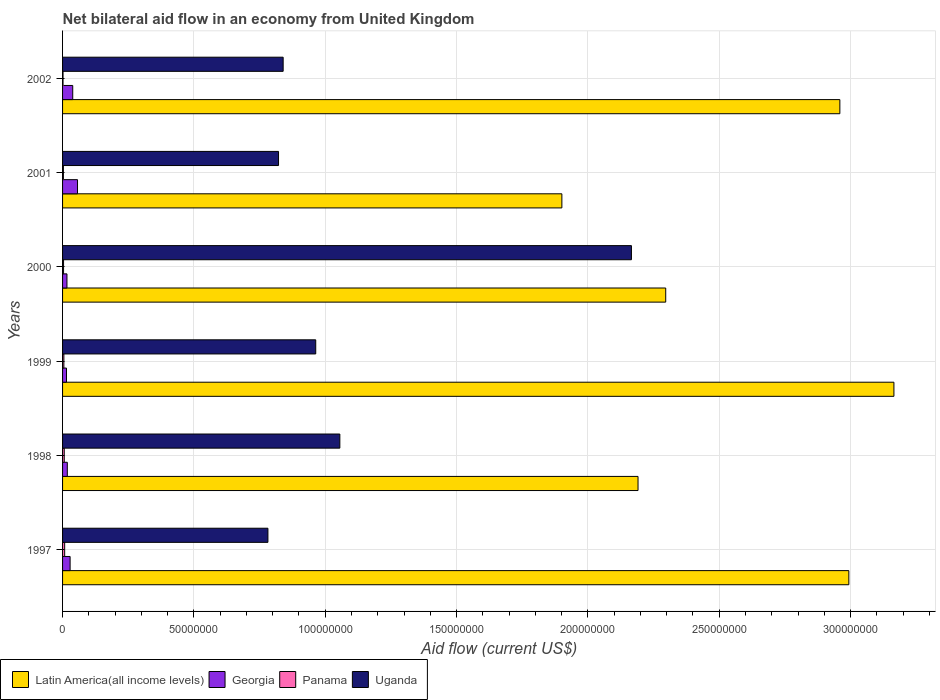How many groups of bars are there?
Provide a short and direct response. 6. Are the number of bars per tick equal to the number of legend labels?
Offer a terse response. Yes. Are the number of bars on each tick of the Y-axis equal?
Ensure brevity in your answer.  Yes. What is the label of the 6th group of bars from the top?
Provide a succinct answer. 1997. In how many cases, is the number of bars for a given year not equal to the number of legend labels?
Ensure brevity in your answer.  0. What is the net bilateral aid flow in Latin America(all income levels) in 1997?
Make the answer very short. 2.99e+08. Across all years, what is the minimum net bilateral aid flow in Georgia?
Your response must be concise. 1.50e+06. What is the total net bilateral aid flow in Panama in the graph?
Keep it short and to the point. 2.82e+06. What is the difference between the net bilateral aid flow in Latin America(all income levels) in 1998 and the net bilateral aid flow in Georgia in 2002?
Provide a succinct answer. 2.15e+08. In the year 1997, what is the difference between the net bilateral aid flow in Uganda and net bilateral aid flow in Panama?
Your answer should be compact. 7.74e+07. What is the ratio of the net bilateral aid flow in Latin America(all income levels) in 2001 to that in 2002?
Your response must be concise. 0.64. Is the net bilateral aid flow in Georgia in 1997 less than that in 2000?
Provide a short and direct response. No. Is the difference between the net bilateral aid flow in Uganda in 1998 and 2002 greater than the difference between the net bilateral aid flow in Panama in 1998 and 2002?
Give a very brief answer. Yes. What is the difference between the highest and the second highest net bilateral aid flow in Georgia?
Make the answer very short. 1.82e+06. What is the difference between the highest and the lowest net bilateral aid flow in Panama?
Your response must be concise. 6.20e+05. Is the sum of the net bilateral aid flow in Georgia in 2000 and 2002 greater than the maximum net bilateral aid flow in Panama across all years?
Give a very brief answer. Yes. Is it the case that in every year, the sum of the net bilateral aid flow in Georgia and net bilateral aid flow in Uganda is greater than the sum of net bilateral aid flow in Panama and net bilateral aid flow in Latin America(all income levels)?
Make the answer very short. Yes. What does the 4th bar from the top in 1999 represents?
Make the answer very short. Latin America(all income levels). What does the 2nd bar from the bottom in 1999 represents?
Provide a short and direct response. Georgia. Is it the case that in every year, the sum of the net bilateral aid flow in Panama and net bilateral aid flow in Georgia is greater than the net bilateral aid flow in Uganda?
Provide a short and direct response. No. Are all the bars in the graph horizontal?
Provide a short and direct response. Yes. How many years are there in the graph?
Provide a short and direct response. 6. What is the difference between two consecutive major ticks on the X-axis?
Offer a terse response. 5.00e+07. Does the graph contain any zero values?
Offer a very short reply. No. Where does the legend appear in the graph?
Your response must be concise. Bottom left. How are the legend labels stacked?
Offer a terse response. Horizontal. What is the title of the graph?
Your answer should be compact. Net bilateral aid flow in an economy from United Kingdom. What is the label or title of the Y-axis?
Give a very brief answer. Years. What is the Aid flow (current US$) of Latin America(all income levels) in 1997?
Your answer should be compact. 2.99e+08. What is the Aid flow (current US$) of Georgia in 1997?
Offer a very short reply. 2.87e+06. What is the Aid flow (current US$) in Panama in 1997?
Make the answer very short. 8.00e+05. What is the Aid flow (current US$) of Uganda in 1997?
Keep it short and to the point. 7.82e+07. What is the Aid flow (current US$) of Latin America(all income levels) in 1998?
Provide a succinct answer. 2.19e+08. What is the Aid flow (current US$) of Georgia in 1998?
Your answer should be compact. 1.81e+06. What is the Aid flow (current US$) of Panama in 1998?
Ensure brevity in your answer.  6.40e+05. What is the Aid flow (current US$) of Uganda in 1998?
Give a very brief answer. 1.06e+08. What is the Aid flow (current US$) in Latin America(all income levels) in 1999?
Offer a very short reply. 3.16e+08. What is the Aid flow (current US$) in Georgia in 1999?
Your response must be concise. 1.50e+06. What is the Aid flow (current US$) in Panama in 1999?
Make the answer very short. 5.00e+05. What is the Aid flow (current US$) in Uganda in 1999?
Ensure brevity in your answer.  9.64e+07. What is the Aid flow (current US$) in Latin America(all income levels) in 2000?
Offer a very short reply. 2.30e+08. What is the Aid flow (current US$) of Georgia in 2000?
Give a very brief answer. 1.67e+06. What is the Aid flow (current US$) of Uganda in 2000?
Your answer should be very brief. 2.17e+08. What is the Aid flow (current US$) of Latin America(all income levels) in 2001?
Your answer should be compact. 1.90e+08. What is the Aid flow (current US$) in Georgia in 2001?
Offer a very short reply. 5.69e+06. What is the Aid flow (current US$) in Uganda in 2001?
Give a very brief answer. 8.22e+07. What is the Aid flow (current US$) of Latin America(all income levels) in 2002?
Provide a succinct answer. 2.96e+08. What is the Aid flow (current US$) of Georgia in 2002?
Your answer should be very brief. 3.87e+06. What is the Aid flow (current US$) in Uganda in 2002?
Ensure brevity in your answer.  8.40e+07. Across all years, what is the maximum Aid flow (current US$) of Latin America(all income levels)?
Make the answer very short. 3.16e+08. Across all years, what is the maximum Aid flow (current US$) of Georgia?
Keep it short and to the point. 5.69e+06. Across all years, what is the maximum Aid flow (current US$) in Panama?
Your answer should be very brief. 8.00e+05. Across all years, what is the maximum Aid flow (current US$) of Uganda?
Keep it short and to the point. 2.17e+08. Across all years, what is the minimum Aid flow (current US$) in Latin America(all income levels)?
Your answer should be compact. 1.90e+08. Across all years, what is the minimum Aid flow (current US$) in Georgia?
Your answer should be compact. 1.50e+06. Across all years, what is the minimum Aid flow (current US$) in Panama?
Make the answer very short. 1.80e+05. Across all years, what is the minimum Aid flow (current US$) of Uganda?
Your answer should be very brief. 7.82e+07. What is the total Aid flow (current US$) of Latin America(all income levels) in the graph?
Ensure brevity in your answer.  1.55e+09. What is the total Aid flow (current US$) in Georgia in the graph?
Your answer should be compact. 1.74e+07. What is the total Aid flow (current US$) in Panama in the graph?
Give a very brief answer. 2.82e+06. What is the total Aid flow (current US$) of Uganda in the graph?
Offer a very short reply. 6.63e+08. What is the difference between the Aid flow (current US$) of Latin America(all income levels) in 1997 and that in 1998?
Offer a very short reply. 8.03e+07. What is the difference between the Aid flow (current US$) in Georgia in 1997 and that in 1998?
Your answer should be very brief. 1.06e+06. What is the difference between the Aid flow (current US$) in Uganda in 1997 and that in 1998?
Provide a short and direct response. -2.74e+07. What is the difference between the Aid flow (current US$) in Latin America(all income levels) in 1997 and that in 1999?
Your answer should be compact. -1.72e+07. What is the difference between the Aid flow (current US$) in Georgia in 1997 and that in 1999?
Offer a terse response. 1.37e+06. What is the difference between the Aid flow (current US$) of Panama in 1997 and that in 1999?
Keep it short and to the point. 3.00e+05. What is the difference between the Aid flow (current US$) of Uganda in 1997 and that in 1999?
Offer a terse response. -1.82e+07. What is the difference between the Aid flow (current US$) in Latin America(all income levels) in 1997 and that in 2000?
Ensure brevity in your answer.  6.97e+07. What is the difference between the Aid flow (current US$) of Georgia in 1997 and that in 2000?
Ensure brevity in your answer.  1.20e+06. What is the difference between the Aid flow (current US$) of Uganda in 1997 and that in 2000?
Offer a terse response. -1.38e+08. What is the difference between the Aid flow (current US$) of Latin America(all income levels) in 1997 and that in 2001?
Your response must be concise. 1.09e+08. What is the difference between the Aid flow (current US$) in Georgia in 1997 and that in 2001?
Provide a succinct answer. -2.82e+06. What is the difference between the Aid flow (current US$) of Uganda in 1997 and that in 2001?
Provide a short and direct response. -4.04e+06. What is the difference between the Aid flow (current US$) of Latin America(all income levels) in 1997 and that in 2002?
Your answer should be compact. 3.42e+06. What is the difference between the Aid flow (current US$) of Georgia in 1997 and that in 2002?
Your answer should be very brief. -1.00e+06. What is the difference between the Aid flow (current US$) of Panama in 1997 and that in 2002?
Provide a short and direct response. 6.20e+05. What is the difference between the Aid flow (current US$) of Uganda in 1997 and that in 2002?
Offer a very short reply. -5.80e+06. What is the difference between the Aid flow (current US$) in Latin America(all income levels) in 1998 and that in 1999?
Keep it short and to the point. -9.74e+07. What is the difference between the Aid flow (current US$) of Georgia in 1998 and that in 1999?
Offer a terse response. 3.10e+05. What is the difference between the Aid flow (current US$) of Uganda in 1998 and that in 1999?
Ensure brevity in your answer.  9.18e+06. What is the difference between the Aid flow (current US$) in Latin America(all income levels) in 1998 and that in 2000?
Give a very brief answer. -1.05e+07. What is the difference between the Aid flow (current US$) in Panama in 1998 and that in 2000?
Offer a terse response. 2.60e+05. What is the difference between the Aid flow (current US$) of Uganda in 1998 and that in 2000?
Offer a very short reply. -1.11e+08. What is the difference between the Aid flow (current US$) of Latin America(all income levels) in 1998 and that in 2001?
Give a very brief answer. 2.90e+07. What is the difference between the Aid flow (current US$) of Georgia in 1998 and that in 2001?
Your response must be concise. -3.88e+06. What is the difference between the Aid flow (current US$) in Uganda in 1998 and that in 2001?
Give a very brief answer. 2.33e+07. What is the difference between the Aid flow (current US$) in Latin America(all income levels) in 1998 and that in 2002?
Your answer should be compact. -7.68e+07. What is the difference between the Aid flow (current US$) of Georgia in 1998 and that in 2002?
Make the answer very short. -2.06e+06. What is the difference between the Aid flow (current US$) in Uganda in 1998 and that in 2002?
Offer a terse response. 2.16e+07. What is the difference between the Aid flow (current US$) in Latin America(all income levels) in 1999 and that in 2000?
Your answer should be compact. 8.69e+07. What is the difference between the Aid flow (current US$) of Georgia in 1999 and that in 2000?
Ensure brevity in your answer.  -1.70e+05. What is the difference between the Aid flow (current US$) in Uganda in 1999 and that in 2000?
Offer a terse response. -1.20e+08. What is the difference between the Aid flow (current US$) of Latin America(all income levels) in 1999 and that in 2001?
Your answer should be very brief. 1.26e+08. What is the difference between the Aid flow (current US$) in Georgia in 1999 and that in 2001?
Keep it short and to the point. -4.19e+06. What is the difference between the Aid flow (current US$) of Uganda in 1999 and that in 2001?
Keep it short and to the point. 1.42e+07. What is the difference between the Aid flow (current US$) of Latin America(all income levels) in 1999 and that in 2002?
Make the answer very short. 2.06e+07. What is the difference between the Aid flow (current US$) of Georgia in 1999 and that in 2002?
Provide a succinct answer. -2.37e+06. What is the difference between the Aid flow (current US$) in Uganda in 1999 and that in 2002?
Your response must be concise. 1.24e+07. What is the difference between the Aid flow (current US$) of Latin America(all income levels) in 2000 and that in 2001?
Offer a terse response. 3.95e+07. What is the difference between the Aid flow (current US$) in Georgia in 2000 and that in 2001?
Offer a very short reply. -4.02e+06. What is the difference between the Aid flow (current US$) in Panama in 2000 and that in 2001?
Keep it short and to the point. 6.00e+04. What is the difference between the Aid flow (current US$) of Uganda in 2000 and that in 2001?
Offer a very short reply. 1.34e+08. What is the difference between the Aid flow (current US$) of Latin America(all income levels) in 2000 and that in 2002?
Give a very brief answer. -6.63e+07. What is the difference between the Aid flow (current US$) of Georgia in 2000 and that in 2002?
Keep it short and to the point. -2.20e+06. What is the difference between the Aid flow (current US$) of Uganda in 2000 and that in 2002?
Offer a terse response. 1.33e+08. What is the difference between the Aid flow (current US$) of Latin America(all income levels) in 2001 and that in 2002?
Offer a very short reply. -1.06e+08. What is the difference between the Aid flow (current US$) of Georgia in 2001 and that in 2002?
Your response must be concise. 1.82e+06. What is the difference between the Aid flow (current US$) of Uganda in 2001 and that in 2002?
Ensure brevity in your answer.  -1.76e+06. What is the difference between the Aid flow (current US$) of Latin America(all income levels) in 1997 and the Aid flow (current US$) of Georgia in 1998?
Offer a terse response. 2.98e+08. What is the difference between the Aid flow (current US$) in Latin America(all income levels) in 1997 and the Aid flow (current US$) in Panama in 1998?
Your answer should be compact. 2.99e+08. What is the difference between the Aid flow (current US$) in Latin America(all income levels) in 1997 and the Aid flow (current US$) in Uganda in 1998?
Keep it short and to the point. 1.94e+08. What is the difference between the Aid flow (current US$) of Georgia in 1997 and the Aid flow (current US$) of Panama in 1998?
Offer a very short reply. 2.23e+06. What is the difference between the Aid flow (current US$) of Georgia in 1997 and the Aid flow (current US$) of Uganda in 1998?
Your answer should be compact. -1.03e+08. What is the difference between the Aid flow (current US$) in Panama in 1997 and the Aid flow (current US$) in Uganda in 1998?
Offer a terse response. -1.05e+08. What is the difference between the Aid flow (current US$) of Latin America(all income levels) in 1997 and the Aid flow (current US$) of Georgia in 1999?
Offer a very short reply. 2.98e+08. What is the difference between the Aid flow (current US$) in Latin America(all income levels) in 1997 and the Aid flow (current US$) in Panama in 1999?
Offer a terse response. 2.99e+08. What is the difference between the Aid flow (current US$) of Latin America(all income levels) in 1997 and the Aid flow (current US$) of Uganda in 1999?
Offer a terse response. 2.03e+08. What is the difference between the Aid flow (current US$) of Georgia in 1997 and the Aid flow (current US$) of Panama in 1999?
Offer a very short reply. 2.37e+06. What is the difference between the Aid flow (current US$) in Georgia in 1997 and the Aid flow (current US$) in Uganda in 1999?
Give a very brief answer. -9.35e+07. What is the difference between the Aid flow (current US$) in Panama in 1997 and the Aid flow (current US$) in Uganda in 1999?
Your answer should be very brief. -9.56e+07. What is the difference between the Aid flow (current US$) in Latin America(all income levels) in 1997 and the Aid flow (current US$) in Georgia in 2000?
Ensure brevity in your answer.  2.98e+08. What is the difference between the Aid flow (current US$) in Latin America(all income levels) in 1997 and the Aid flow (current US$) in Panama in 2000?
Make the answer very short. 2.99e+08. What is the difference between the Aid flow (current US$) of Latin America(all income levels) in 1997 and the Aid flow (current US$) of Uganda in 2000?
Your response must be concise. 8.28e+07. What is the difference between the Aid flow (current US$) of Georgia in 1997 and the Aid flow (current US$) of Panama in 2000?
Keep it short and to the point. 2.49e+06. What is the difference between the Aid flow (current US$) of Georgia in 1997 and the Aid flow (current US$) of Uganda in 2000?
Keep it short and to the point. -2.14e+08. What is the difference between the Aid flow (current US$) in Panama in 1997 and the Aid flow (current US$) in Uganda in 2000?
Your response must be concise. -2.16e+08. What is the difference between the Aid flow (current US$) of Latin America(all income levels) in 1997 and the Aid flow (current US$) of Georgia in 2001?
Provide a succinct answer. 2.94e+08. What is the difference between the Aid flow (current US$) of Latin America(all income levels) in 1997 and the Aid flow (current US$) of Panama in 2001?
Offer a terse response. 2.99e+08. What is the difference between the Aid flow (current US$) of Latin America(all income levels) in 1997 and the Aid flow (current US$) of Uganda in 2001?
Provide a succinct answer. 2.17e+08. What is the difference between the Aid flow (current US$) in Georgia in 1997 and the Aid flow (current US$) in Panama in 2001?
Your answer should be compact. 2.55e+06. What is the difference between the Aid flow (current US$) of Georgia in 1997 and the Aid flow (current US$) of Uganda in 2001?
Provide a short and direct response. -7.94e+07. What is the difference between the Aid flow (current US$) of Panama in 1997 and the Aid flow (current US$) of Uganda in 2001?
Ensure brevity in your answer.  -8.14e+07. What is the difference between the Aid flow (current US$) in Latin America(all income levels) in 1997 and the Aid flow (current US$) in Georgia in 2002?
Offer a very short reply. 2.95e+08. What is the difference between the Aid flow (current US$) of Latin America(all income levels) in 1997 and the Aid flow (current US$) of Panama in 2002?
Offer a terse response. 2.99e+08. What is the difference between the Aid flow (current US$) of Latin America(all income levels) in 1997 and the Aid flow (current US$) of Uganda in 2002?
Provide a succinct answer. 2.15e+08. What is the difference between the Aid flow (current US$) in Georgia in 1997 and the Aid flow (current US$) in Panama in 2002?
Your answer should be compact. 2.69e+06. What is the difference between the Aid flow (current US$) of Georgia in 1997 and the Aid flow (current US$) of Uganda in 2002?
Give a very brief answer. -8.11e+07. What is the difference between the Aid flow (current US$) of Panama in 1997 and the Aid flow (current US$) of Uganda in 2002?
Keep it short and to the point. -8.32e+07. What is the difference between the Aid flow (current US$) in Latin America(all income levels) in 1998 and the Aid flow (current US$) in Georgia in 1999?
Give a very brief answer. 2.18e+08. What is the difference between the Aid flow (current US$) of Latin America(all income levels) in 1998 and the Aid flow (current US$) of Panama in 1999?
Your answer should be compact. 2.19e+08. What is the difference between the Aid flow (current US$) in Latin America(all income levels) in 1998 and the Aid flow (current US$) in Uganda in 1999?
Give a very brief answer. 1.23e+08. What is the difference between the Aid flow (current US$) in Georgia in 1998 and the Aid flow (current US$) in Panama in 1999?
Offer a very short reply. 1.31e+06. What is the difference between the Aid flow (current US$) in Georgia in 1998 and the Aid flow (current US$) in Uganda in 1999?
Your answer should be very brief. -9.46e+07. What is the difference between the Aid flow (current US$) of Panama in 1998 and the Aid flow (current US$) of Uganda in 1999?
Provide a succinct answer. -9.57e+07. What is the difference between the Aid flow (current US$) in Latin America(all income levels) in 1998 and the Aid flow (current US$) in Georgia in 2000?
Give a very brief answer. 2.17e+08. What is the difference between the Aid flow (current US$) of Latin America(all income levels) in 1998 and the Aid flow (current US$) of Panama in 2000?
Provide a short and direct response. 2.19e+08. What is the difference between the Aid flow (current US$) in Latin America(all income levels) in 1998 and the Aid flow (current US$) in Uganda in 2000?
Offer a terse response. 2.51e+06. What is the difference between the Aid flow (current US$) of Georgia in 1998 and the Aid flow (current US$) of Panama in 2000?
Your answer should be compact. 1.43e+06. What is the difference between the Aid flow (current US$) in Georgia in 1998 and the Aid flow (current US$) in Uganda in 2000?
Provide a succinct answer. -2.15e+08. What is the difference between the Aid flow (current US$) in Panama in 1998 and the Aid flow (current US$) in Uganda in 2000?
Ensure brevity in your answer.  -2.16e+08. What is the difference between the Aid flow (current US$) of Latin America(all income levels) in 1998 and the Aid flow (current US$) of Georgia in 2001?
Your response must be concise. 2.13e+08. What is the difference between the Aid flow (current US$) in Latin America(all income levels) in 1998 and the Aid flow (current US$) in Panama in 2001?
Give a very brief answer. 2.19e+08. What is the difference between the Aid flow (current US$) in Latin America(all income levels) in 1998 and the Aid flow (current US$) in Uganda in 2001?
Your response must be concise. 1.37e+08. What is the difference between the Aid flow (current US$) in Georgia in 1998 and the Aid flow (current US$) in Panama in 2001?
Offer a very short reply. 1.49e+06. What is the difference between the Aid flow (current US$) of Georgia in 1998 and the Aid flow (current US$) of Uganda in 2001?
Give a very brief answer. -8.04e+07. What is the difference between the Aid flow (current US$) in Panama in 1998 and the Aid flow (current US$) in Uganda in 2001?
Your response must be concise. -8.16e+07. What is the difference between the Aid flow (current US$) of Latin America(all income levels) in 1998 and the Aid flow (current US$) of Georgia in 2002?
Offer a terse response. 2.15e+08. What is the difference between the Aid flow (current US$) of Latin America(all income levels) in 1998 and the Aid flow (current US$) of Panama in 2002?
Give a very brief answer. 2.19e+08. What is the difference between the Aid flow (current US$) of Latin America(all income levels) in 1998 and the Aid flow (current US$) of Uganda in 2002?
Give a very brief answer. 1.35e+08. What is the difference between the Aid flow (current US$) of Georgia in 1998 and the Aid flow (current US$) of Panama in 2002?
Give a very brief answer. 1.63e+06. What is the difference between the Aid flow (current US$) of Georgia in 1998 and the Aid flow (current US$) of Uganda in 2002?
Provide a short and direct response. -8.22e+07. What is the difference between the Aid flow (current US$) in Panama in 1998 and the Aid flow (current US$) in Uganda in 2002?
Provide a succinct answer. -8.33e+07. What is the difference between the Aid flow (current US$) of Latin America(all income levels) in 1999 and the Aid flow (current US$) of Georgia in 2000?
Give a very brief answer. 3.15e+08. What is the difference between the Aid flow (current US$) of Latin America(all income levels) in 1999 and the Aid flow (current US$) of Panama in 2000?
Your answer should be very brief. 3.16e+08. What is the difference between the Aid flow (current US$) in Latin America(all income levels) in 1999 and the Aid flow (current US$) in Uganda in 2000?
Ensure brevity in your answer.  9.99e+07. What is the difference between the Aid flow (current US$) of Georgia in 1999 and the Aid flow (current US$) of Panama in 2000?
Make the answer very short. 1.12e+06. What is the difference between the Aid flow (current US$) in Georgia in 1999 and the Aid flow (current US$) in Uganda in 2000?
Make the answer very short. -2.15e+08. What is the difference between the Aid flow (current US$) in Panama in 1999 and the Aid flow (current US$) in Uganda in 2000?
Provide a succinct answer. -2.16e+08. What is the difference between the Aid flow (current US$) of Latin America(all income levels) in 1999 and the Aid flow (current US$) of Georgia in 2001?
Offer a very short reply. 3.11e+08. What is the difference between the Aid flow (current US$) of Latin America(all income levels) in 1999 and the Aid flow (current US$) of Panama in 2001?
Provide a succinct answer. 3.16e+08. What is the difference between the Aid flow (current US$) of Latin America(all income levels) in 1999 and the Aid flow (current US$) of Uganda in 2001?
Keep it short and to the point. 2.34e+08. What is the difference between the Aid flow (current US$) of Georgia in 1999 and the Aid flow (current US$) of Panama in 2001?
Keep it short and to the point. 1.18e+06. What is the difference between the Aid flow (current US$) in Georgia in 1999 and the Aid flow (current US$) in Uganda in 2001?
Offer a very short reply. -8.07e+07. What is the difference between the Aid flow (current US$) of Panama in 1999 and the Aid flow (current US$) of Uganda in 2001?
Your answer should be compact. -8.17e+07. What is the difference between the Aid flow (current US$) in Latin America(all income levels) in 1999 and the Aid flow (current US$) in Georgia in 2002?
Offer a very short reply. 3.13e+08. What is the difference between the Aid flow (current US$) of Latin America(all income levels) in 1999 and the Aid flow (current US$) of Panama in 2002?
Keep it short and to the point. 3.16e+08. What is the difference between the Aid flow (current US$) in Latin America(all income levels) in 1999 and the Aid flow (current US$) in Uganda in 2002?
Provide a succinct answer. 2.33e+08. What is the difference between the Aid flow (current US$) in Georgia in 1999 and the Aid flow (current US$) in Panama in 2002?
Provide a short and direct response. 1.32e+06. What is the difference between the Aid flow (current US$) in Georgia in 1999 and the Aid flow (current US$) in Uganda in 2002?
Your response must be concise. -8.25e+07. What is the difference between the Aid flow (current US$) in Panama in 1999 and the Aid flow (current US$) in Uganda in 2002?
Ensure brevity in your answer.  -8.35e+07. What is the difference between the Aid flow (current US$) of Latin America(all income levels) in 2000 and the Aid flow (current US$) of Georgia in 2001?
Keep it short and to the point. 2.24e+08. What is the difference between the Aid flow (current US$) of Latin America(all income levels) in 2000 and the Aid flow (current US$) of Panama in 2001?
Provide a succinct answer. 2.29e+08. What is the difference between the Aid flow (current US$) of Latin America(all income levels) in 2000 and the Aid flow (current US$) of Uganda in 2001?
Provide a short and direct response. 1.47e+08. What is the difference between the Aid flow (current US$) of Georgia in 2000 and the Aid flow (current US$) of Panama in 2001?
Keep it short and to the point. 1.35e+06. What is the difference between the Aid flow (current US$) in Georgia in 2000 and the Aid flow (current US$) in Uganda in 2001?
Provide a short and direct response. -8.06e+07. What is the difference between the Aid flow (current US$) in Panama in 2000 and the Aid flow (current US$) in Uganda in 2001?
Provide a succinct answer. -8.18e+07. What is the difference between the Aid flow (current US$) of Latin America(all income levels) in 2000 and the Aid flow (current US$) of Georgia in 2002?
Your answer should be compact. 2.26e+08. What is the difference between the Aid flow (current US$) of Latin America(all income levels) in 2000 and the Aid flow (current US$) of Panama in 2002?
Offer a very short reply. 2.29e+08. What is the difference between the Aid flow (current US$) of Latin America(all income levels) in 2000 and the Aid flow (current US$) of Uganda in 2002?
Provide a short and direct response. 1.46e+08. What is the difference between the Aid flow (current US$) in Georgia in 2000 and the Aid flow (current US$) in Panama in 2002?
Keep it short and to the point. 1.49e+06. What is the difference between the Aid flow (current US$) in Georgia in 2000 and the Aid flow (current US$) in Uganda in 2002?
Offer a very short reply. -8.23e+07. What is the difference between the Aid flow (current US$) in Panama in 2000 and the Aid flow (current US$) in Uganda in 2002?
Give a very brief answer. -8.36e+07. What is the difference between the Aid flow (current US$) in Latin America(all income levels) in 2001 and the Aid flow (current US$) in Georgia in 2002?
Your answer should be compact. 1.86e+08. What is the difference between the Aid flow (current US$) of Latin America(all income levels) in 2001 and the Aid flow (current US$) of Panama in 2002?
Offer a very short reply. 1.90e+08. What is the difference between the Aid flow (current US$) of Latin America(all income levels) in 2001 and the Aid flow (current US$) of Uganda in 2002?
Make the answer very short. 1.06e+08. What is the difference between the Aid flow (current US$) of Georgia in 2001 and the Aid flow (current US$) of Panama in 2002?
Your answer should be very brief. 5.51e+06. What is the difference between the Aid flow (current US$) of Georgia in 2001 and the Aid flow (current US$) of Uganda in 2002?
Offer a terse response. -7.83e+07. What is the difference between the Aid flow (current US$) of Panama in 2001 and the Aid flow (current US$) of Uganda in 2002?
Ensure brevity in your answer.  -8.37e+07. What is the average Aid flow (current US$) in Latin America(all income levels) per year?
Ensure brevity in your answer.  2.58e+08. What is the average Aid flow (current US$) in Georgia per year?
Provide a short and direct response. 2.90e+06. What is the average Aid flow (current US$) of Panama per year?
Your answer should be compact. 4.70e+05. What is the average Aid flow (current US$) of Uganda per year?
Make the answer very short. 1.10e+08. In the year 1997, what is the difference between the Aid flow (current US$) of Latin America(all income levels) and Aid flow (current US$) of Georgia?
Provide a succinct answer. 2.96e+08. In the year 1997, what is the difference between the Aid flow (current US$) of Latin America(all income levels) and Aid flow (current US$) of Panama?
Offer a very short reply. 2.99e+08. In the year 1997, what is the difference between the Aid flow (current US$) of Latin America(all income levels) and Aid flow (current US$) of Uganda?
Provide a short and direct response. 2.21e+08. In the year 1997, what is the difference between the Aid flow (current US$) in Georgia and Aid flow (current US$) in Panama?
Offer a very short reply. 2.07e+06. In the year 1997, what is the difference between the Aid flow (current US$) of Georgia and Aid flow (current US$) of Uganda?
Make the answer very short. -7.53e+07. In the year 1997, what is the difference between the Aid flow (current US$) in Panama and Aid flow (current US$) in Uganda?
Your response must be concise. -7.74e+07. In the year 1998, what is the difference between the Aid flow (current US$) in Latin America(all income levels) and Aid flow (current US$) in Georgia?
Your answer should be compact. 2.17e+08. In the year 1998, what is the difference between the Aid flow (current US$) in Latin America(all income levels) and Aid flow (current US$) in Panama?
Your answer should be very brief. 2.18e+08. In the year 1998, what is the difference between the Aid flow (current US$) of Latin America(all income levels) and Aid flow (current US$) of Uganda?
Make the answer very short. 1.14e+08. In the year 1998, what is the difference between the Aid flow (current US$) in Georgia and Aid flow (current US$) in Panama?
Provide a short and direct response. 1.17e+06. In the year 1998, what is the difference between the Aid flow (current US$) of Georgia and Aid flow (current US$) of Uganda?
Your answer should be compact. -1.04e+08. In the year 1998, what is the difference between the Aid flow (current US$) of Panama and Aid flow (current US$) of Uganda?
Your answer should be compact. -1.05e+08. In the year 1999, what is the difference between the Aid flow (current US$) in Latin America(all income levels) and Aid flow (current US$) in Georgia?
Make the answer very short. 3.15e+08. In the year 1999, what is the difference between the Aid flow (current US$) of Latin America(all income levels) and Aid flow (current US$) of Panama?
Keep it short and to the point. 3.16e+08. In the year 1999, what is the difference between the Aid flow (current US$) of Latin America(all income levels) and Aid flow (current US$) of Uganda?
Your response must be concise. 2.20e+08. In the year 1999, what is the difference between the Aid flow (current US$) in Georgia and Aid flow (current US$) in Panama?
Make the answer very short. 1.00e+06. In the year 1999, what is the difference between the Aid flow (current US$) of Georgia and Aid flow (current US$) of Uganda?
Your answer should be compact. -9.49e+07. In the year 1999, what is the difference between the Aid flow (current US$) in Panama and Aid flow (current US$) in Uganda?
Make the answer very short. -9.59e+07. In the year 2000, what is the difference between the Aid flow (current US$) of Latin America(all income levels) and Aid flow (current US$) of Georgia?
Offer a very short reply. 2.28e+08. In the year 2000, what is the difference between the Aid flow (current US$) of Latin America(all income levels) and Aid flow (current US$) of Panama?
Offer a very short reply. 2.29e+08. In the year 2000, what is the difference between the Aid flow (current US$) of Latin America(all income levels) and Aid flow (current US$) of Uganda?
Keep it short and to the point. 1.30e+07. In the year 2000, what is the difference between the Aid flow (current US$) in Georgia and Aid flow (current US$) in Panama?
Your answer should be compact. 1.29e+06. In the year 2000, what is the difference between the Aid flow (current US$) of Georgia and Aid flow (current US$) of Uganda?
Offer a terse response. -2.15e+08. In the year 2000, what is the difference between the Aid flow (current US$) of Panama and Aid flow (current US$) of Uganda?
Ensure brevity in your answer.  -2.16e+08. In the year 2001, what is the difference between the Aid flow (current US$) of Latin America(all income levels) and Aid flow (current US$) of Georgia?
Give a very brief answer. 1.84e+08. In the year 2001, what is the difference between the Aid flow (current US$) of Latin America(all income levels) and Aid flow (current US$) of Panama?
Offer a very short reply. 1.90e+08. In the year 2001, what is the difference between the Aid flow (current US$) in Latin America(all income levels) and Aid flow (current US$) in Uganda?
Your answer should be compact. 1.08e+08. In the year 2001, what is the difference between the Aid flow (current US$) in Georgia and Aid flow (current US$) in Panama?
Your answer should be very brief. 5.37e+06. In the year 2001, what is the difference between the Aid flow (current US$) of Georgia and Aid flow (current US$) of Uganda?
Provide a succinct answer. -7.65e+07. In the year 2001, what is the difference between the Aid flow (current US$) in Panama and Aid flow (current US$) in Uganda?
Keep it short and to the point. -8.19e+07. In the year 2002, what is the difference between the Aid flow (current US$) of Latin America(all income levels) and Aid flow (current US$) of Georgia?
Give a very brief answer. 2.92e+08. In the year 2002, what is the difference between the Aid flow (current US$) in Latin America(all income levels) and Aid flow (current US$) in Panama?
Keep it short and to the point. 2.96e+08. In the year 2002, what is the difference between the Aid flow (current US$) in Latin America(all income levels) and Aid flow (current US$) in Uganda?
Your answer should be compact. 2.12e+08. In the year 2002, what is the difference between the Aid flow (current US$) in Georgia and Aid flow (current US$) in Panama?
Provide a succinct answer. 3.69e+06. In the year 2002, what is the difference between the Aid flow (current US$) in Georgia and Aid flow (current US$) in Uganda?
Offer a terse response. -8.01e+07. In the year 2002, what is the difference between the Aid flow (current US$) of Panama and Aid flow (current US$) of Uganda?
Provide a succinct answer. -8.38e+07. What is the ratio of the Aid flow (current US$) in Latin America(all income levels) in 1997 to that in 1998?
Your response must be concise. 1.37. What is the ratio of the Aid flow (current US$) in Georgia in 1997 to that in 1998?
Your answer should be compact. 1.59. What is the ratio of the Aid flow (current US$) of Panama in 1997 to that in 1998?
Ensure brevity in your answer.  1.25. What is the ratio of the Aid flow (current US$) of Uganda in 1997 to that in 1998?
Your response must be concise. 0.74. What is the ratio of the Aid flow (current US$) of Latin America(all income levels) in 1997 to that in 1999?
Give a very brief answer. 0.95. What is the ratio of the Aid flow (current US$) of Georgia in 1997 to that in 1999?
Provide a succinct answer. 1.91. What is the ratio of the Aid flow (current US$) in Panama in 1997 to that in 1999?
Offer a terse response. 1.6. What is the ratio of the Aid flow (current US$) of Uganda in 1997 to that in 1999?
Your answer should be very brief. 0.81. What is the ratio of the Aid flow (current US$) of Latin America(all income levels) in 1997 to that in 2000?
Offer a terse response. 1.3. What is the ratio of the Aid flow (current US$) of Georgia in 1997 to that in 2000?
Your answer should be very brief. 1.72. What is the ratio of the Aid flow (current US$) in Panama in 1997 to that in 2000?
Offer a terse response. 2.11. What is the ratio of the Aid flow (current US$) in Uganda in 1997 to that in 2000?
Your response must be concise. 0.36. What is the ratio of the Aid flow (current US$) in Latin America(all income levels) in 1997 to that in 2001?
Provide a succinct answer. 1.57. What is the ratio of the Aid flow (current US$) in Georgia in 1997 to that in 2001?
Your response must be concise. 0.5. What is the ratio of the Aid flow (current US$) of Uganda in 1997 to that in 2001?
Give a very brief answer. 0.95. What is the ratio of the Aid flow (current US$) in Latin America(all income levels) in 1997 to that in 2002?
Keep it short and to the point. 1.01. What is the ratio of the Aid flow (current US$) of Georgia in 1997 to that in 2002?
Make the answer very short. 0.74. What is the ratio of the Aid flow (current US$) in Panama in 1997 to that in 2002?
Your response must be concise. 4.44. What is the ratio of the Aid flow (current US$) in Uganda in 1997 to that in 2002?
Your answer should be compact. 0.93. What is the ratio of the Aid flow (current US$) in Latin America(all income levels) in 1998 to that in 1999?
Provide a short and direct response. 0.69. What is the ratio of the Aid flow (current US$) of Georgia in 1998 to that in 1999?
Ensure brevity in your answer.  1.21. What is the ratio of the Aid flow (current US$) of Panama in 1998 to that in 1999?
Offer a very short reply. 1.28. What is the ratio of the Aid flow (current US$) of Uganda in 1998 to that in 1999?
Ensure brevity in your answer.  1.1. What is the ratio of the Aid flow (current US$) of Latin America(all income levels) in 1998 to that in 2000?
Offer a terse response. 0.95. What is the ratio of the Aid flow (current US$) in Georgia in 1998 to that in 2000?
Provide a short and direct response. 1.08. What is the ratio of the Aid flow (current US$) of Panama in 1998 to that in 2000?
Ensure brevity in your answer.  1.68. What is the ratio of the Aid flow (current US$) of Uganda in 1998 to that in 2000?
Give a very brief answer. 0.49. What is the ratio of the Aid flow (current US$) of Latin America(all income levels) in 1998 to that in 2001?
Give a very brief answer. 1.15. What is the ratio of the Aid flow (current US$) in Georgia in 1998 to that in 2001?
Give a very brief answer. 0.32. What is the ratio of the Aid flow (current US$) of Uganda in 1998 to that in 2001?
Your answer should be compact. 1.28. What is the ratio of the Aid flow (current US$) in Latin America(all income levels) in 1998 to that in 2002?
Give a very brief answer. 0.74. What is the ratio of the Aid flow (current US$) in Georgia in 1998 to that in 2002?
Your answer should be compact. 0.47. What is the ratio of the Aid flow (current US$) in Panama in 1998 to that in 2002?
Ensure brevity in your answer.  3.56. What is the ratio of the Aid flow (current US$) in Uganda in 1998 to that in 2002?
Give a very brief answer. 1.26. What is the ratio of the Aid flow (current US$) of Latin America(all income levels) in 1999 to that in 2000?
Offer a very short reply. 1.38. What is the ratio of the Aid flow (current US$) of Georgia in 1999 to that in 2000?
Offer a terse response. 0.9. What is the ratio of the Aid flow (current US$) of Panama in 1999 to that in 2000?
Your answer should be compact. 1.32. What is the ratio of the Aid flow (current US$) of Uganda in 1999 to that in 2000?
Your response must be concise. 0.45. What is the ratio of the Aid flow (current US$) of Latin America(all income levels) in 1999 to that in 2001?
Ensure brevity in your answer.  1.67. What is the ratio of the Aid flow (current US$) of Georgia in 1999 to that in 2001?
Your answer should be compact. 0.26. What is the ratio of the Aid flow (current US$) of Panama in 1999 to that in 2001?
Provide a succinct answer. 1.56. What is the ratio of the Aid flow (current US$) of Uganda in 1999 to that in 2001?
Ensure brevity in your answer.  1.17. What is the ratio of the Aid flow (current US$) of Latin America(all income levels) in 1999 to that in 2002?
Your answer should be compact. 1.07. What is the ratio of the Aid flow (current US$) in Georgia in 1999 to that in 2002?
Your answer should be very brief. 0.39. What is the ratio of the Aid flow (current US$) of Panama in 1999 to that in 2002?
Provide a succinct answer. 2.78. What is the ratio of the Aid flow (current US$) of Uganda in 1999 to that in 2002?
Your answer should be compact. 1.15. What is the ratio of the Aid flow (current US$) of Latin America(all income levels) in 2000 to that in 2001?
Your answer should be compact. 1.21. What is the ratio of the Aid flow (current US$) of Georgia in 2000 to that in 2001?
Ensure brevity in your answer.  0.29. What is the ratio of the Aid flow (current US$) of Panama in 2000 to that in 2001?
Your answer should be compact. 1.19. What is the ratio of the Aid flow (current US$) of Uganda in 2000 to that in 2001?
Your response must be concise. 2.63. What is the ratio of the Aid flow (current US$) in Latin America(all income levels) in 2000 to that in 2002?
Ensure brevity in your answer.  0.78. What is the ratio of the Aid flow (current US$) of Georgia in 2000 to that in 2002?
Make the answer very short. 0.43. What is the ratio of the Aid flow (current US$) of Panama in 2000 to that in 2002?
Provide a short and direct response. 2.11. What is the ratio of the Aid flow (current US$) in Uganda in 2000 to that in 2002?
Offer a very short reply. 2.58. What is the ratio of the Aid flow (current US$) of Latin America(all income levels) in 2001 to that in 2002?
Your answer should be very brief. 0.64. What is the ratio of the Aid flow (current US$) in Georgia in 2001 to that in 2002?
Provide a short and direct response. 1.47. What is the ratio of the Aid flow (current US$) of Panama in 2001 to that in 2002?
Your answer should be compact. 1.78. What is the ratio of the Aid flow (current US$) of Uganda in 2001 to that in 2002?
Offer a terse response. 0.98. What is the difference between the highest and the second highest Aid flow (current US$) of Latin America(all income levels)?
Your response must be concise. 1.72e+07. What is the difference between the highest and the second highest Aid flow (current US$) of Georgia?
Your answer should be very brief. 1.82e+06. What is the difference between the highest and the second highest Aid flow (current US$) of Panama?
Keep it short and to the point. 1.60e+05. What is the difference between the highest and the second highest Aid flow (current US$) of Uganda?
Provide a short and direct response. 1.11e+08. What is the difference between the highest and the lowest Aid flow (current US$) in Latin America(all income levels)?
Provide a short and direct response. 1.26e+08. What is the difference between the highest and the lowest Aid flow (current US$) in Georgia?
Your answer should be compact. 4.19e+06. What is the difference between the highest and the lowest Aid flow (current US$) in Panama?
Provide a succinct answer. 6.20e+05. What is the difference between the highest and the lowest Aid flow (current US$) of Uganda?
Offer a very short reply. 1.38e+08. 